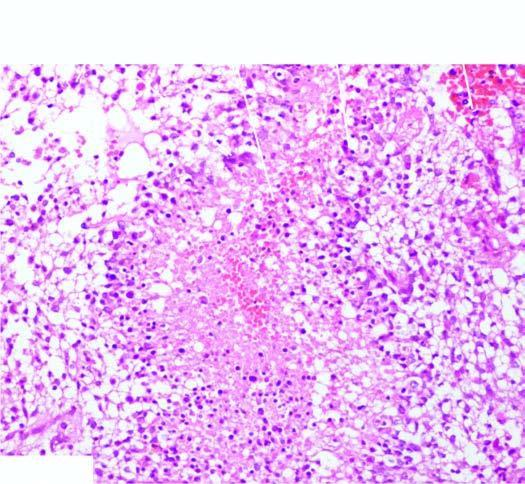what does the tumour have?
Answer the question using a single word or phrase. Areas of necrosis 